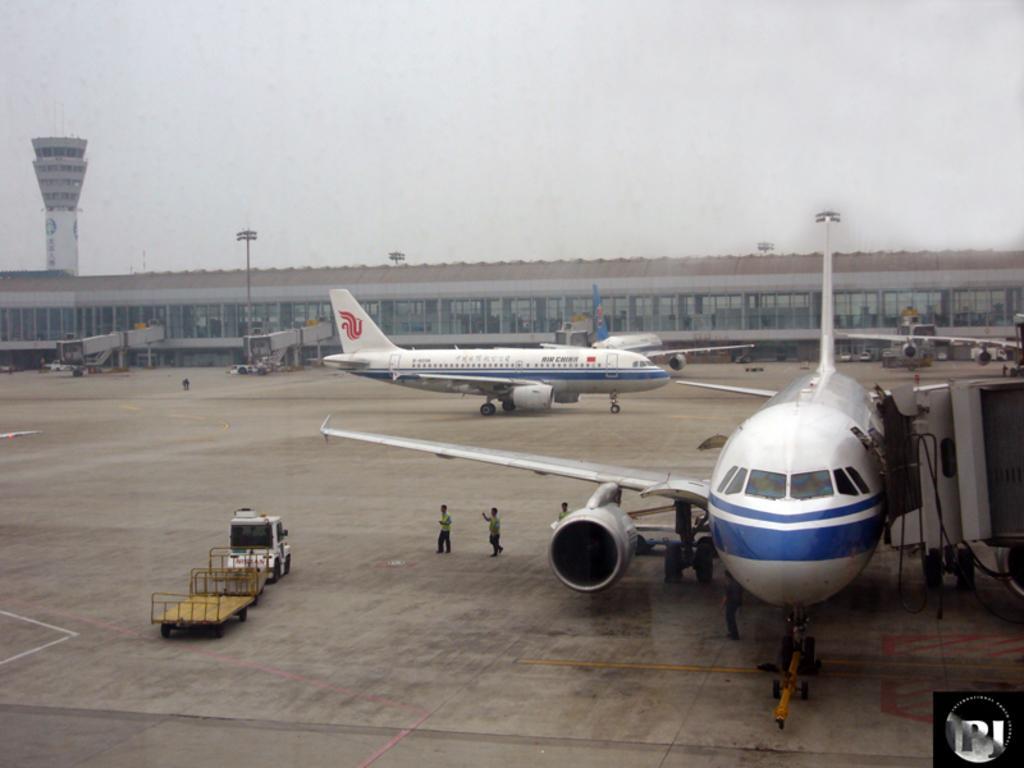How would you summarize this image in a sentence or two? This is an outside view. Here I can see few aeroplanes on the ground and there are few people. On the left side there is a vehicle on the ground. In the background there is a building. At the top, I can see the sky. 